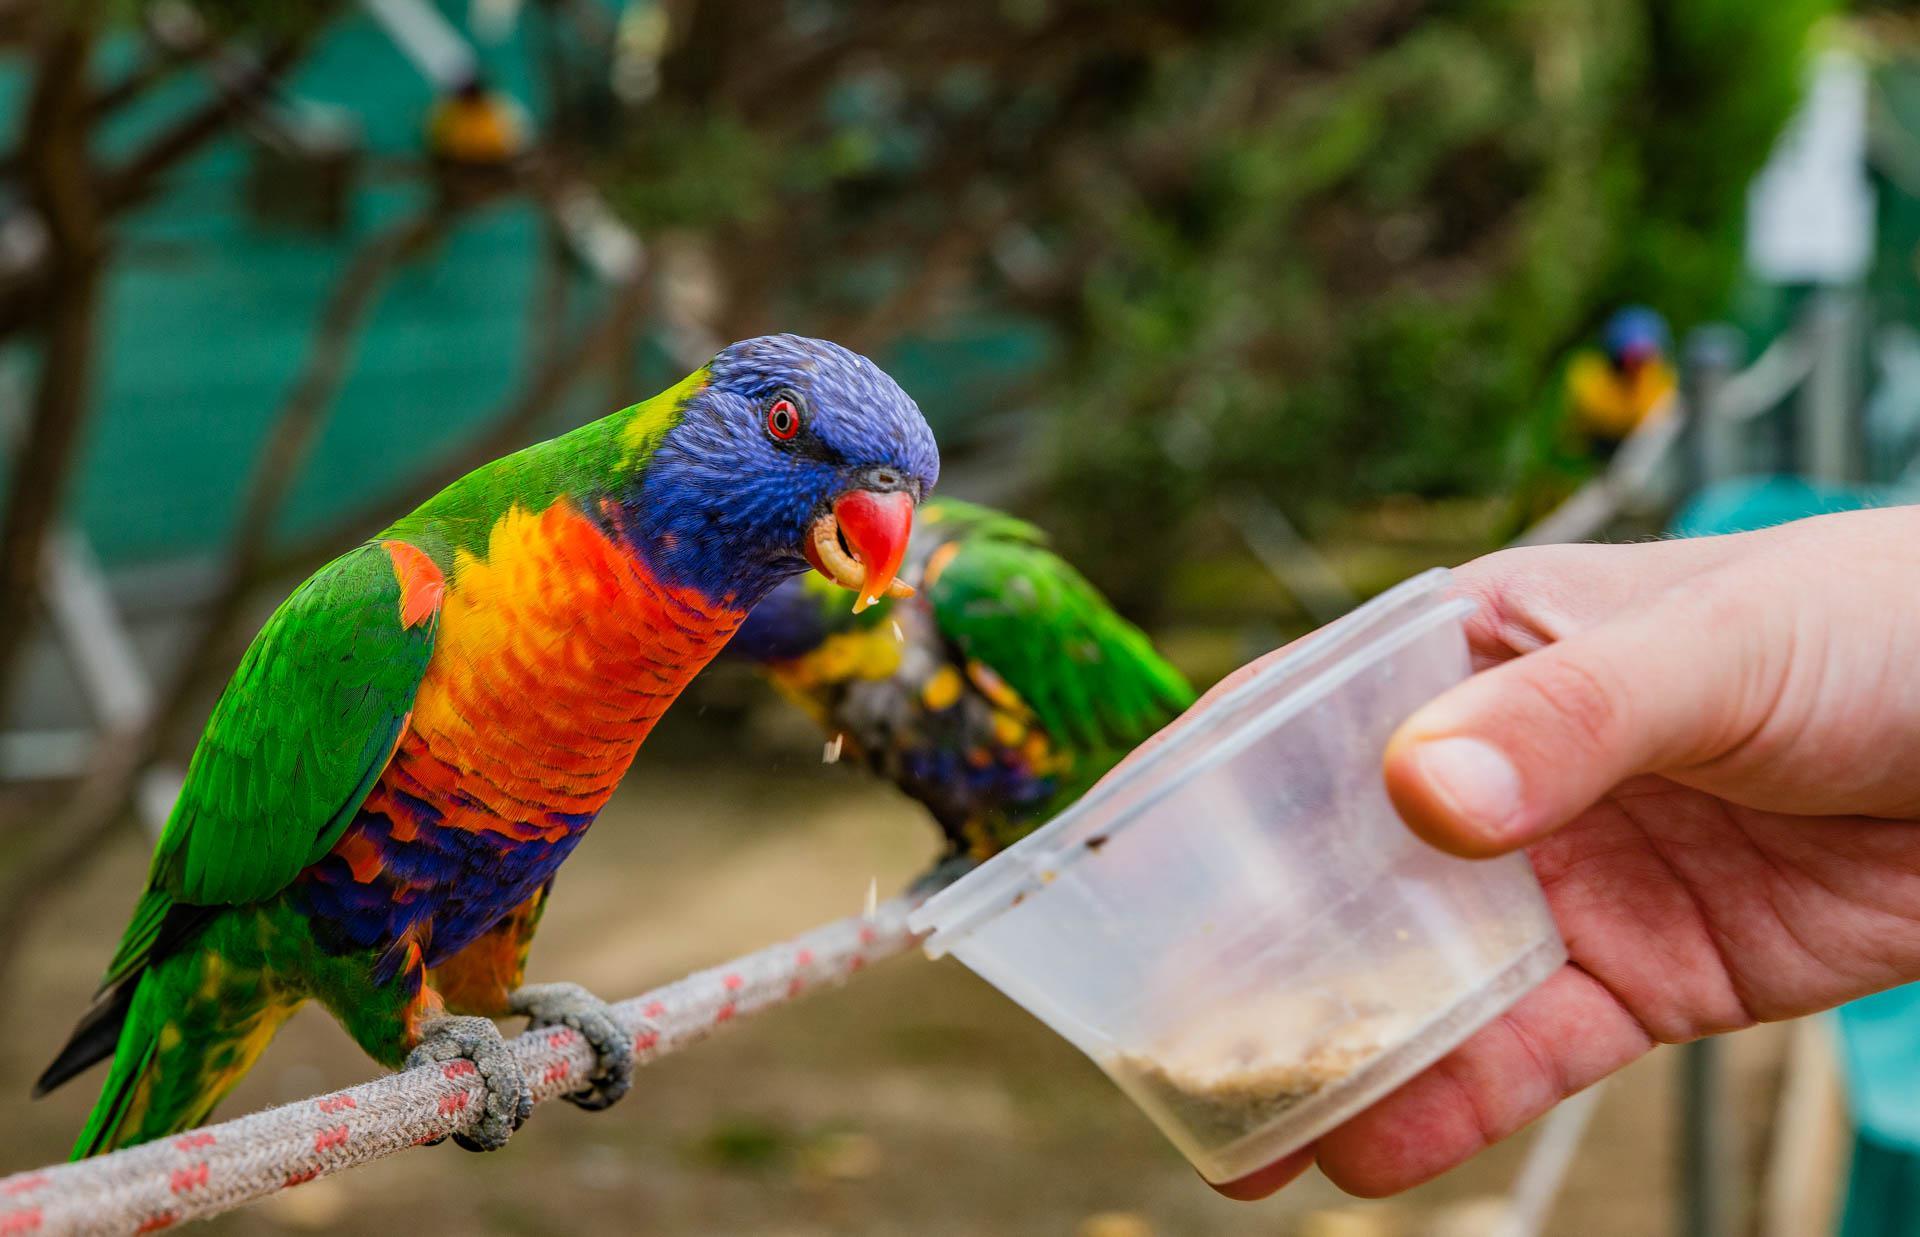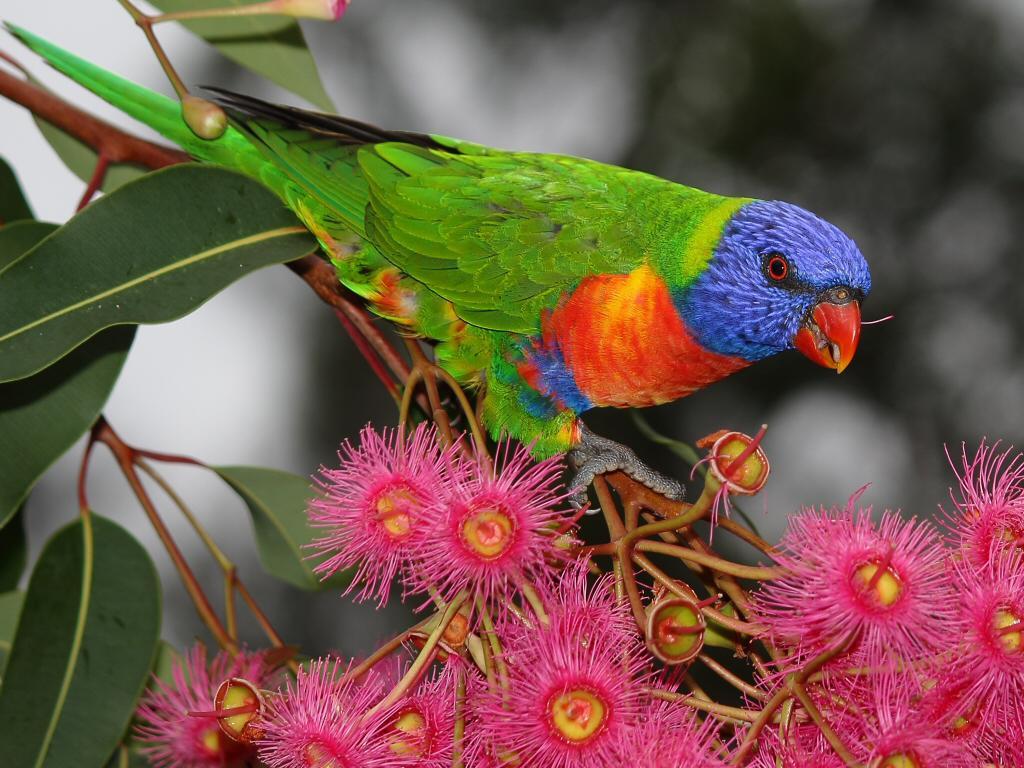The first image is the image on the left, the second image is the image on the right. Examine the images to the left and right. Is the description "A blue-headed bird with non-spread wings is perched among dark pink flowers with tendril petals." accurate? Answer yes or no. Yes. The first image is the image on the left, the second image is the image on the right. Analyze the images presented: Is the assertion "At least one brightly colored bird perches on a branch with pink flowers." valid? Answer yes or no. Yes. 